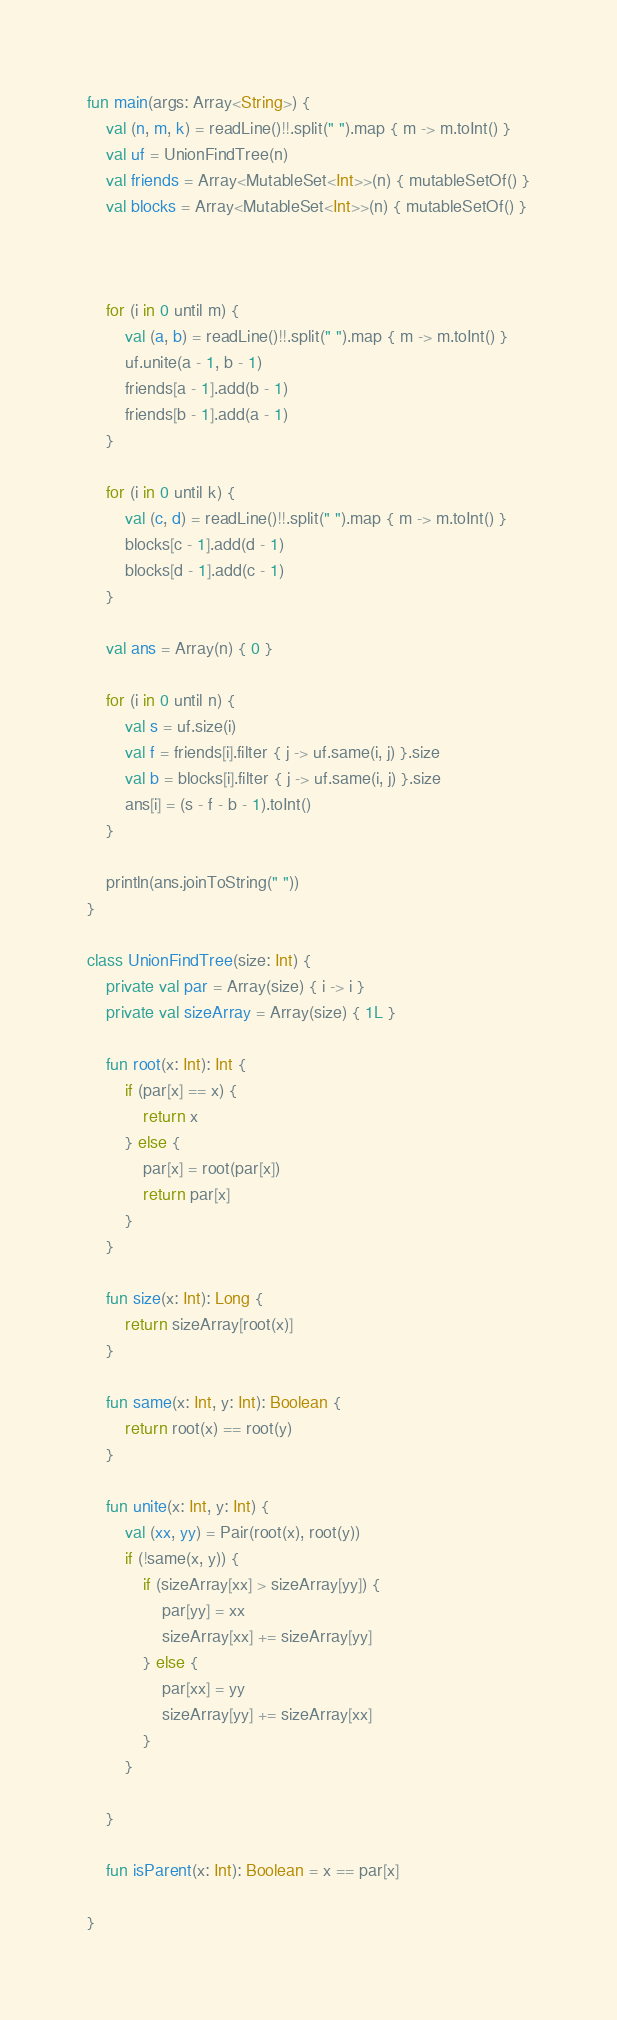<code> <loc_0><loc_0><loc_500><loc_500><_Kotlin_>fun main(args: Array<String>) {
    val (n, m, k) = readLine()!!.split(" ").map { m -> m.toInt() }
    val uf = UnionFindTree(n)
    val friends = Array<MutableSet<Int>>(n) { mutableSetOf() }
    val blocks = Array<MutableSet<Int>>(n) { mutableSetOf() }
    
    
    
    for (i in 0 until m) {
        val (a, b) = readLine()!!.split(" ").map { m -> m.toInt() }
        uf.unite(a - 1, b - 1)
        friends[a - 1].add(b - 1)
        friends[b - 1].add(a - 1)
    }
    
    for (i in 0 until k) {
        val (c, d) = readLine()!!.split(" ").map { m -> m.toInt() }
        blocks[c - 1].add(d - 1)
        blocks[d - 1].add(c - 1)
    }
    
    val ans = Array(n) { 0 }
    
    for (i in 0 until n) {
        val s = uf.size(i)
        val f = friends[i].filter { j -> uf.same(i, j) }.size
        val b = blocks[i].filter { j -> uf.same(i, j) }.size
        ans[i] = (s - f - b - 1).toInt()
    }
    
    println(ans.joinToString(" "))
}

class UnionFindTree(size: Int) {
    private val par = Array(size) { i -> i }
    private val sizeArray = Array(size) { 1L }
    
    fun root(x: Int): Int {
        if (par[x] == x) {
            return x
        } else {
            par[x] = root(par[x])
            return par[x]
        }
    }
    
    fun size(x: Int): Long {
        return sizeArray[root(x)]
    }
    
    fun same(x: Int, y: Int): Boolean {
        return root(x) == root(y)
    }
    
    fun unite(x: Int, y: Int) {
        val (xx, yy) = Pair(root(x), root(y))
        if (!same(x, y)) {
            if (sizeArray[xx] > sizeArray[yy]) {
                par[yy] = xx
                sizeArray[xx] += sizeArray[yy]
            } else {
                par[xx] = yy
                sizeArray[yy] += sizeArray[xx]
            }
        }
        
    }
    
    fun isParent(x: Int): Boolean = x == par[x]
    
}</code> 